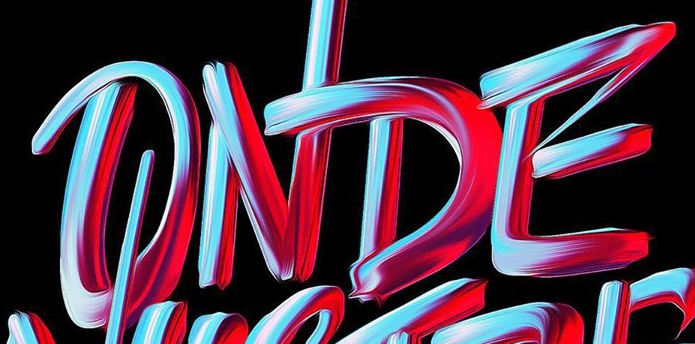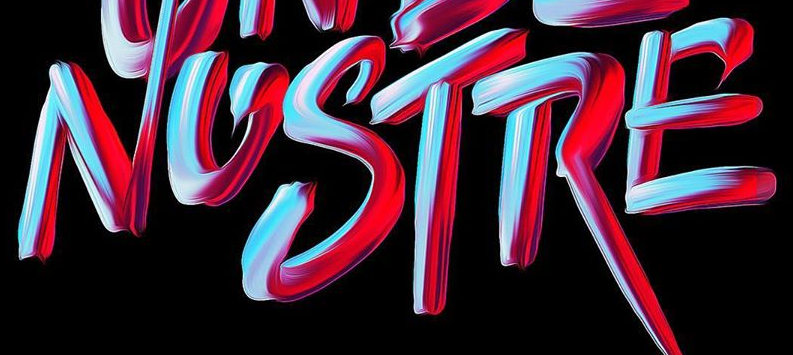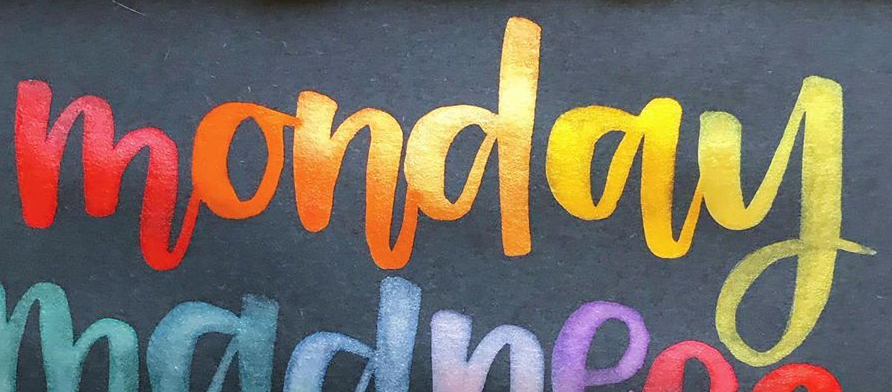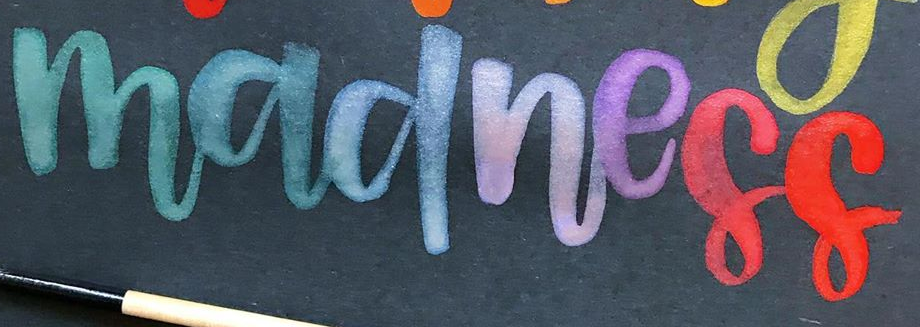Transcribe the words shown in these images in order, separated by a semicolon. ONDE; NOSTRE; monday; madness 